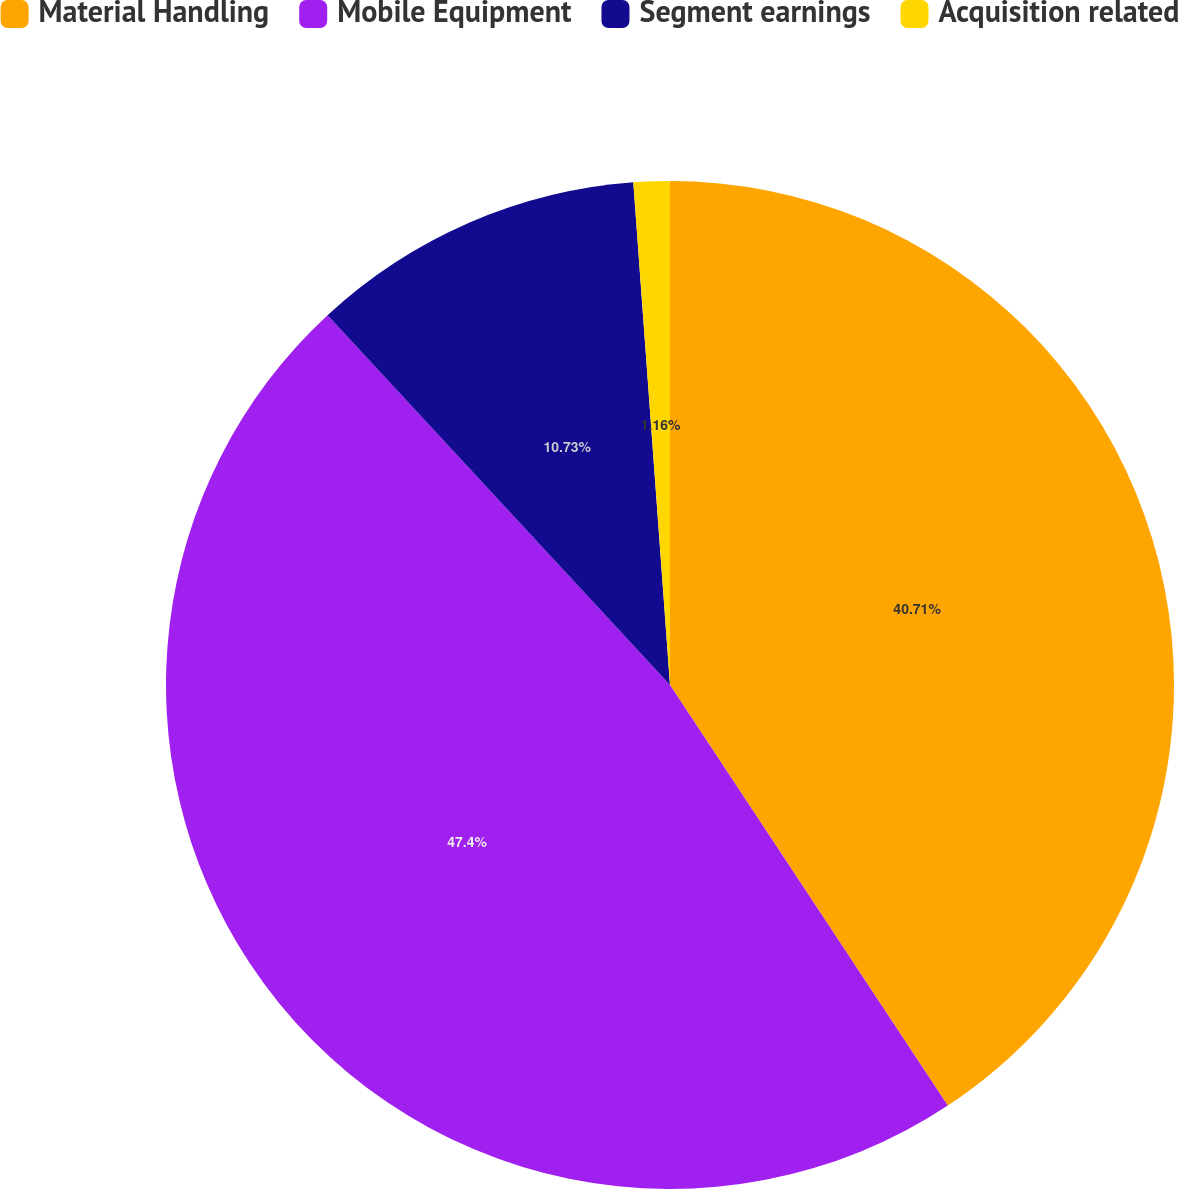Convert chart. <chart><loc_0><loc_0><loc_500><loc_500><pie_chart><fcel>Material Handling<fcel>Mobile Equipment<fcel>Segment earnings<fcel>Acquisition related<nl><fcel>40.71%<fcel>47.4%<fcel>10.73%<fcel>1.16%<nl></chart> 